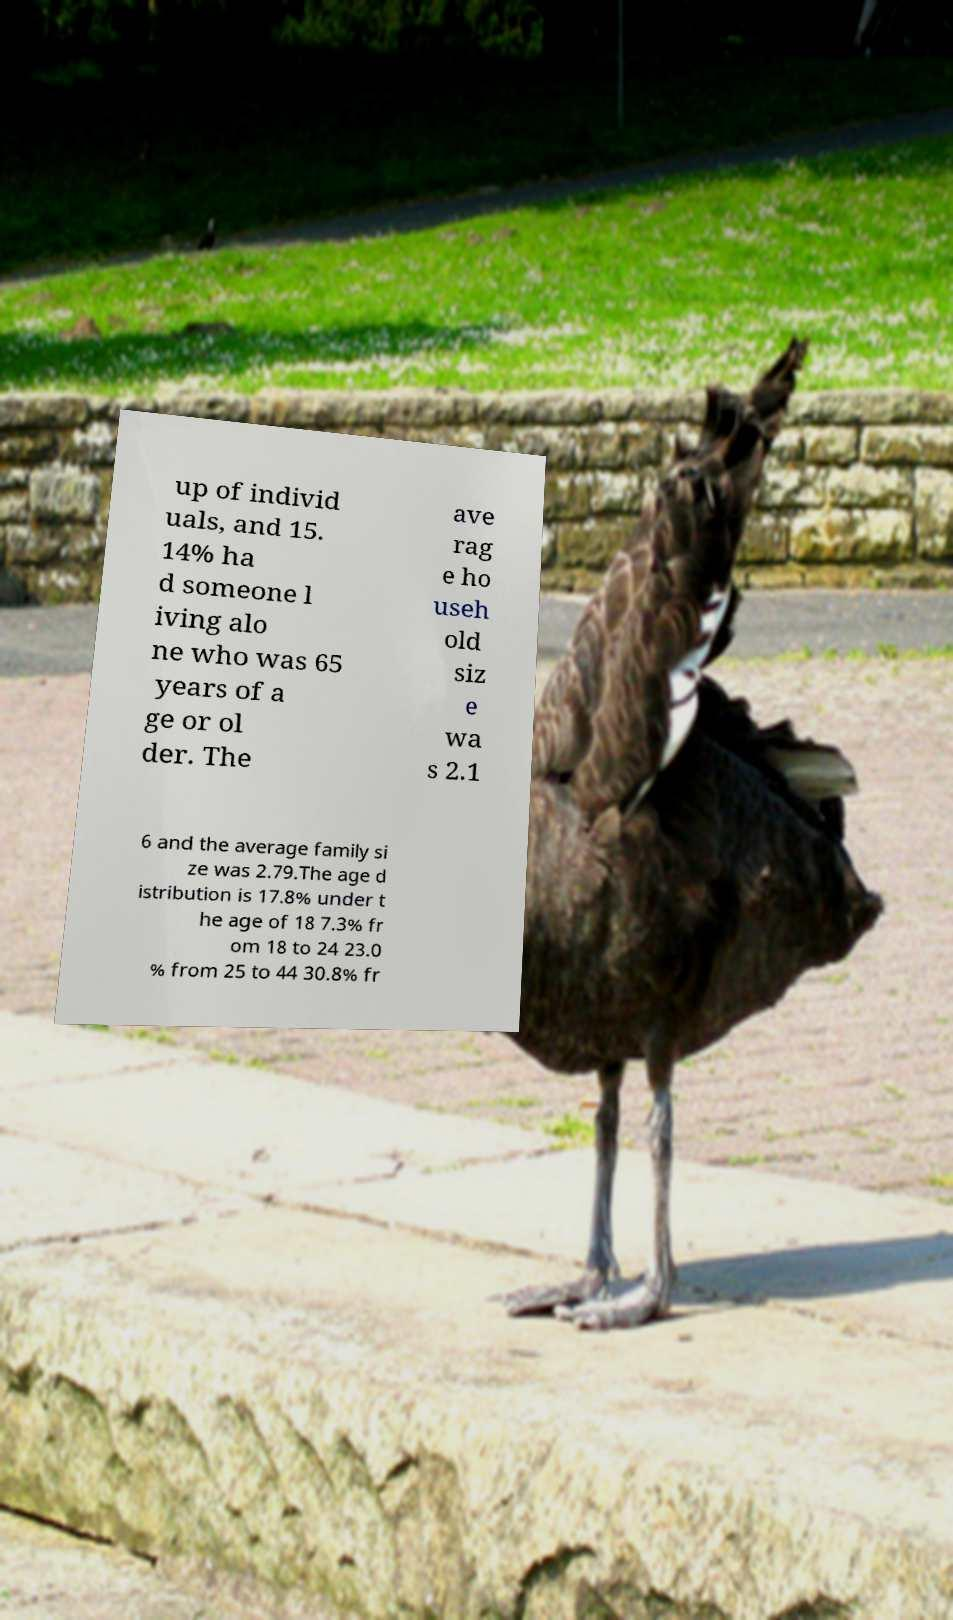Can you accurately transcribe the text from the provided image for me? up of individ uals, and 15. 14% ha d someone l iving alo ne who was 65 years of a ge or ol der. The ave rag e ho useh old siz e wa s 2.1 6 and the average family si ze was 2.79.The age d istribution is 17.8% under t he age of 18 7.3% fr om 18 to 24 23.0 % from 25 to 44 30.8% fr 